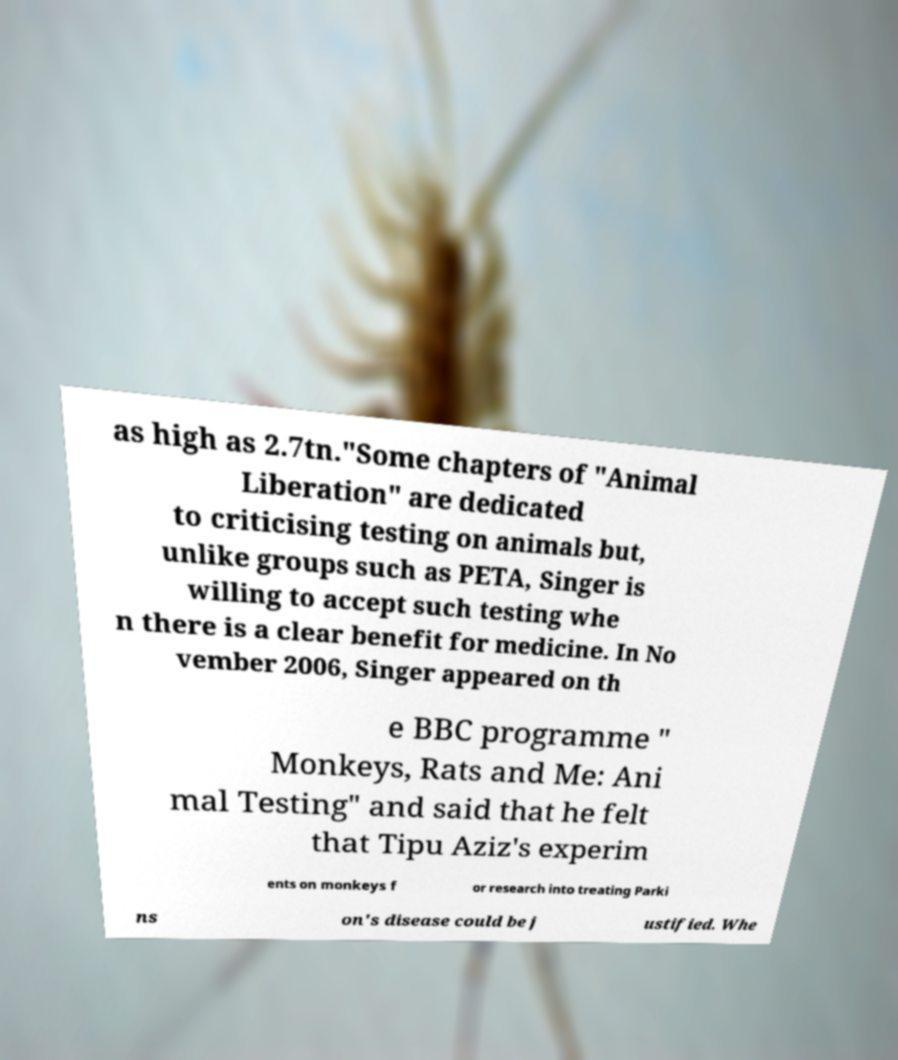Can you accurately transcribe the text from the provided image for me? as high as 2.7tn."Some chapters of "Animal Liberation" are dedicated to criticising testing on animals but, unlike groups such as PETA, Singer is willing to accept such testing whe n there is a clear benefit for medicine. In No vember 2006, Singer appeared on th e BBC programme " Monkeys, Rats and Me: Ani mal Testing" and said that he felt that Tipu Aziz's experim ents on monkeys f or research into treating Parki ns on's disease could be j ustified. Whe 